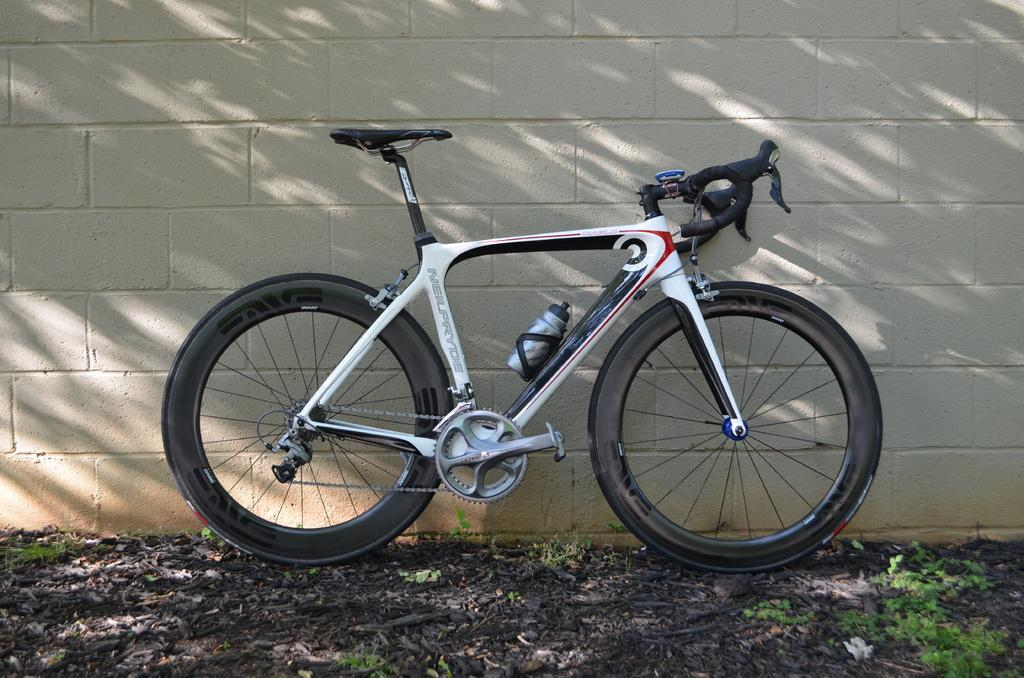What is the main object in the center of the image? There is a cycle in the center of the image. What is placed on the cycle? There is a bottle on the cycle. What type of vegetation is visible at the bottom of the image? There is grass and plants at the bottom of the image. What can be seen in the background of the image? There is a wall in the background of the image. What type of writing can be seen on the turkey in the image? There is no turkey present in the image, and therefore no writing can be seen on it. 